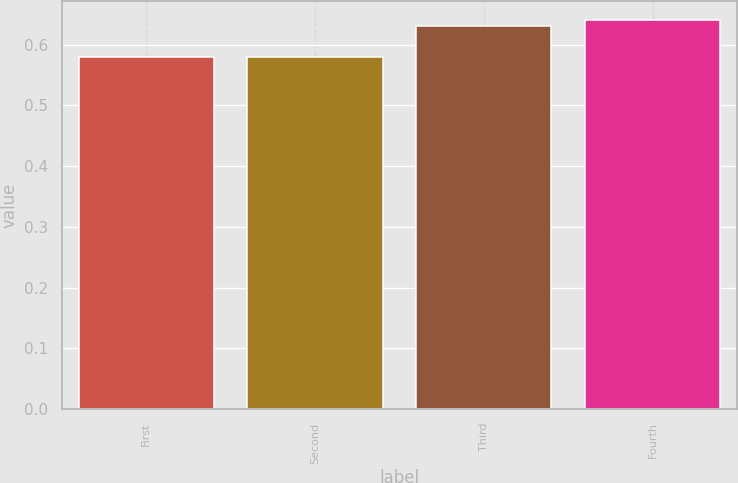Convert chart. <chart><loc_0><loc_0><loc_500><loc_500><bar_chart><fcel>First<fcel>Second<fcel>Third<fcel>Fourth<nl><fcel>0.58<fcel>0.58<fcel>0.63<fcel>0.64<nl></chart> 